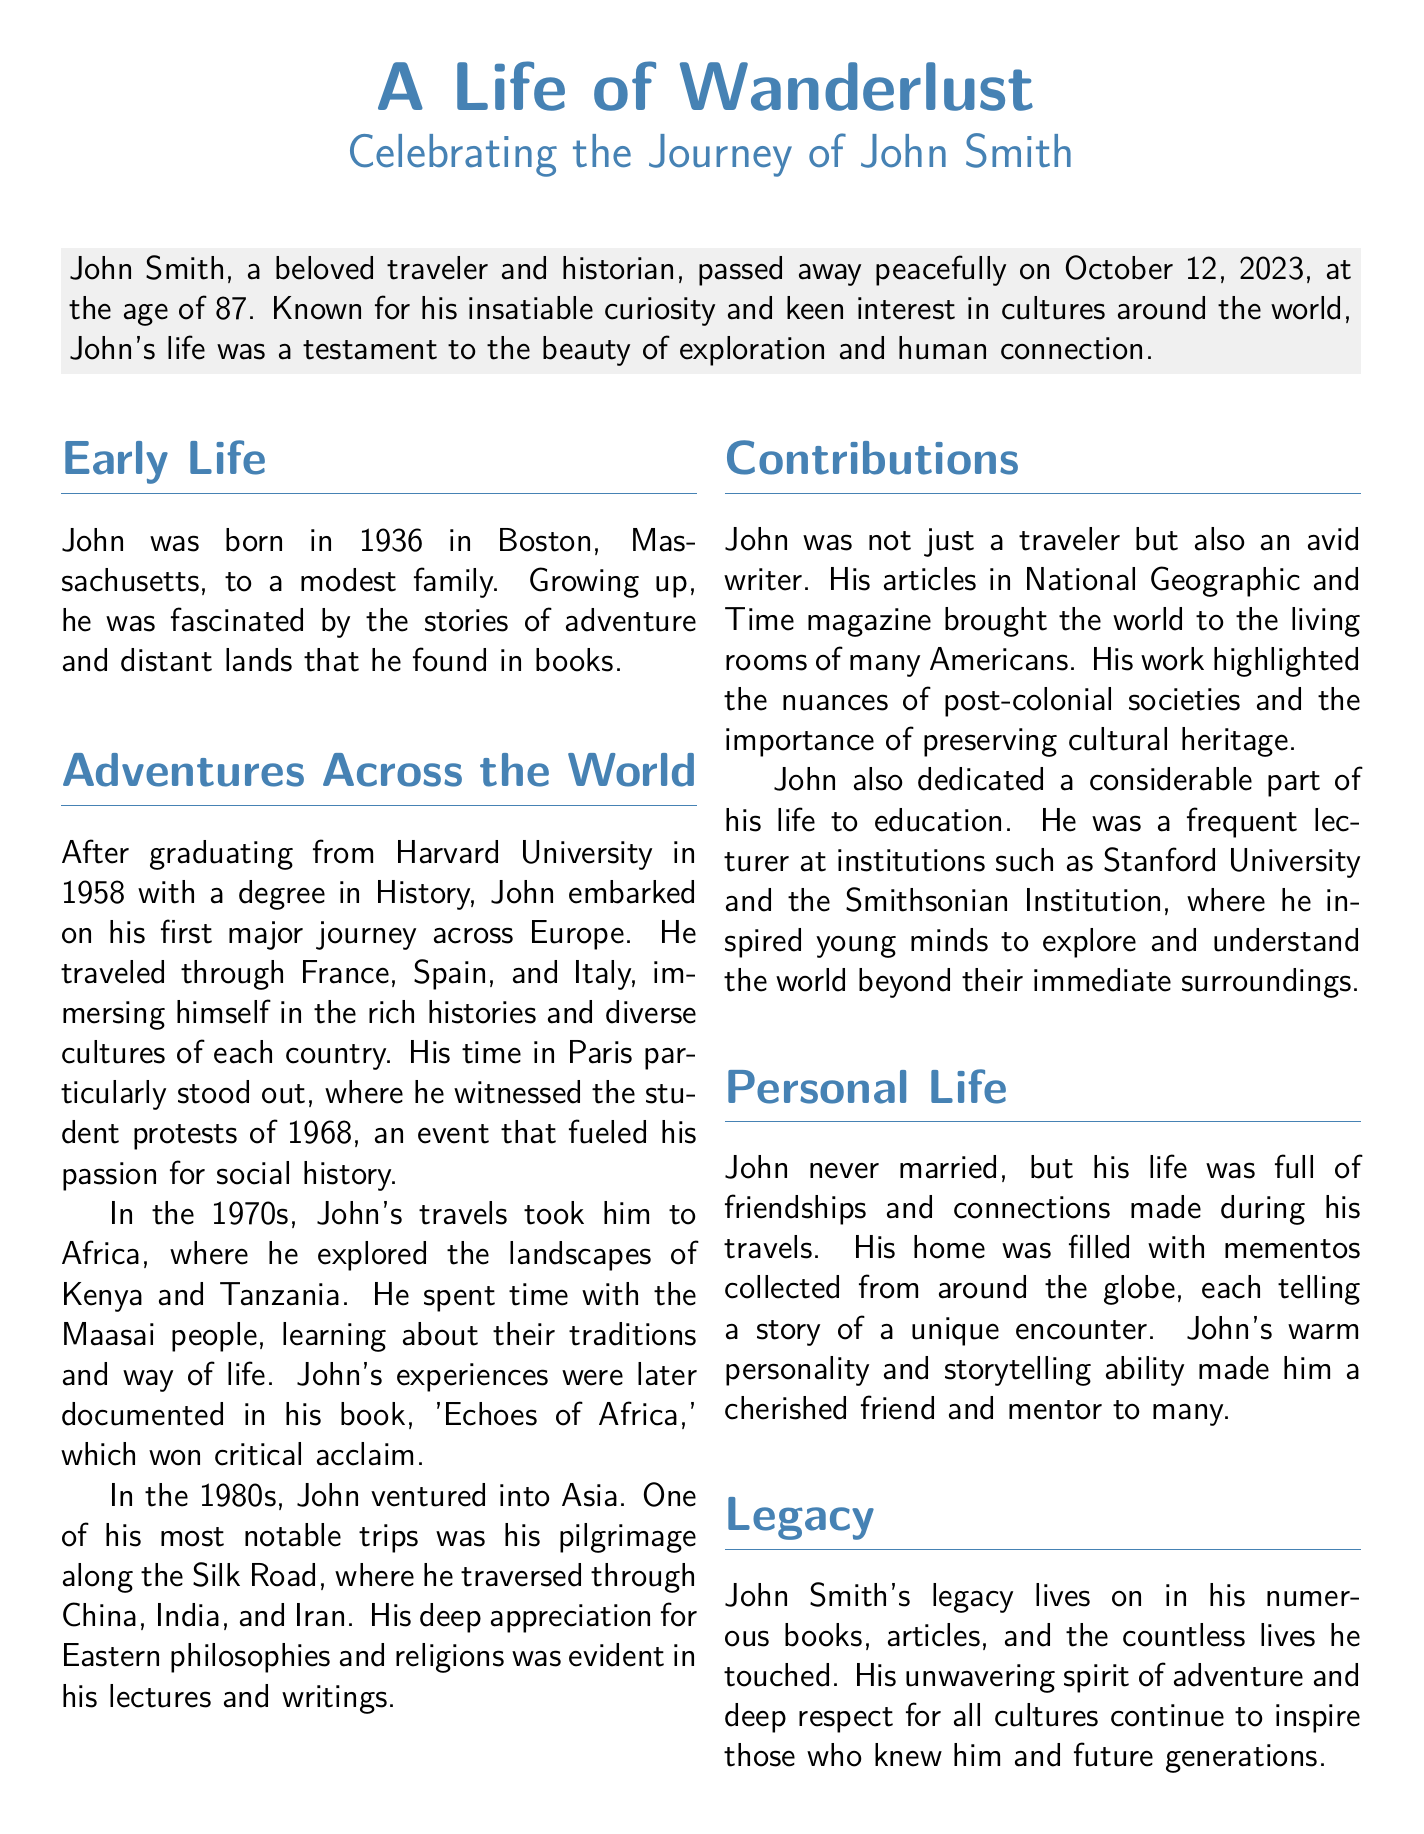What year did John Smith pass away? The document states that John Smith passed away on October 12, 2023.
Answer: 2023 Where was John born? According to the document, John was born in Boston, Massachusetts.
Answer: Boston, Massachusetts What major event did John witness in Paris? The obituary mentions that John witnessed the student protests of 1968 in Paris.
Answer: student protests of 1968 Which organization can people donate to in lieu of flowers? The document suggests donations can be made to the International Rescue Committee.
Answer: International Rescue Committee What was the title of John's acclaimed book about Africa? John's book about Africa is titled 'Echoes of Africa.'
Answer: Echoes of Africa Which university did John frequently lecture at? The document lists Stanford University as one of the institutions where John was a lecturer.
Answer: Stanford University What decade did John travel to Africa? The document states that John traveled to Africa in the 1970s.
Answer: 1970s How old was John when he died? The obituary notes that John was 87 years old at the time of his passing.
Answer: 87 What was John's profession besides being a traveler? In addition to being a traveler, John was also an avid writer.
Answer: writer 